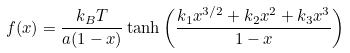Convert formula to latex. <formula><loc_0><loc_0><loc_500><loc_500>f ( x ) = \frac { k _ { B } T } { a ( 1 - x ) } \tanh { \left ( \frac { k _ { 1 } x ^ { 3 / 2 } + k _ { 2 } x ^ { 2 } + k _ { 3 } x ^ { 3 } } { 1 - x } \right ) }</formula> 